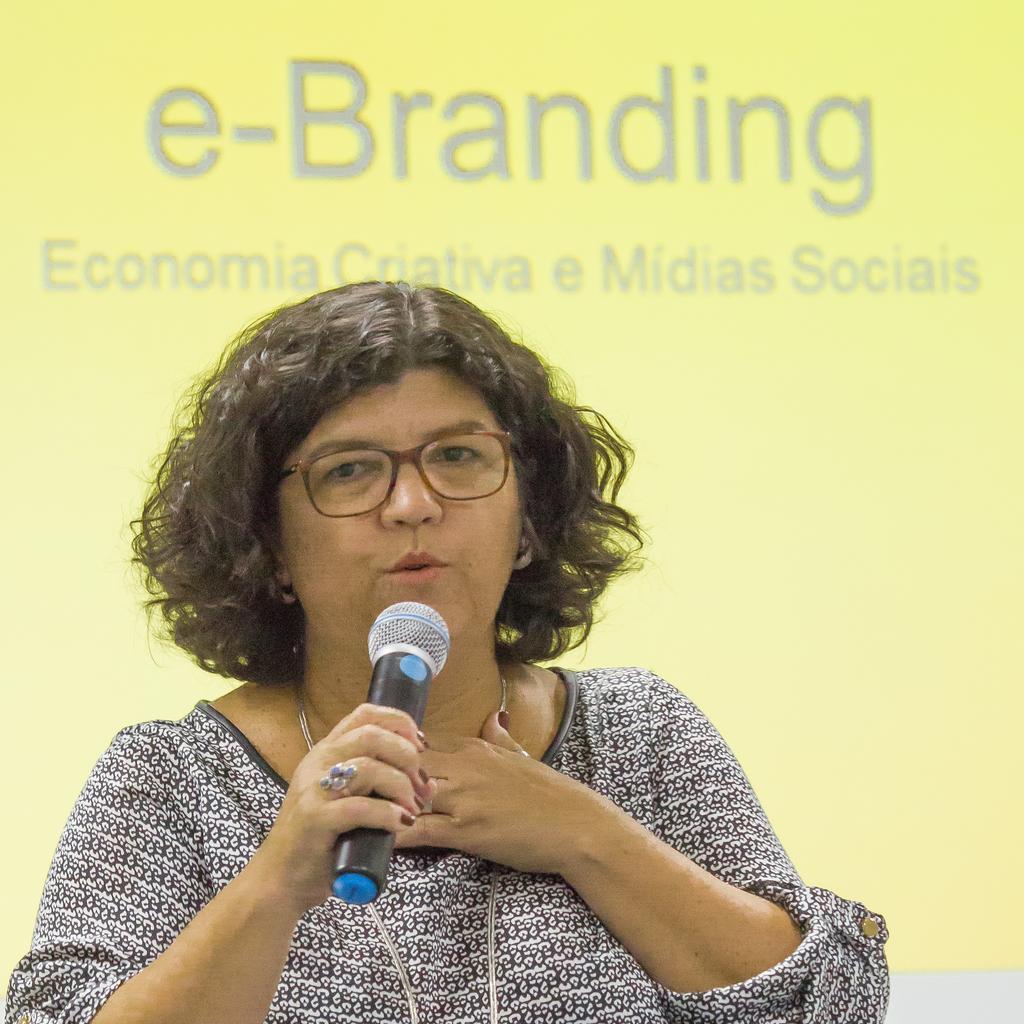Please provide a concise description of this image. In this picture I can see a woman speaking with the help of a microphone and in the background I can see some text. 